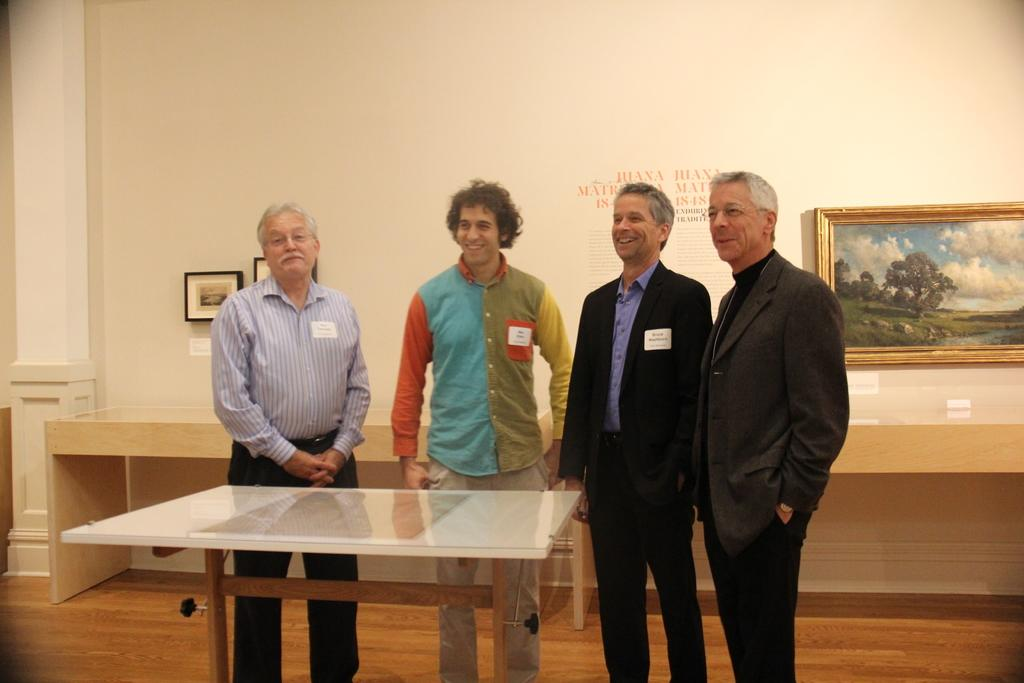How many people are in the image? There are four men in the image. What is the facial expression of the men in the image? The men are smiling. What type of furniture is present in the image? There is a white table in the image. What can be seen on the wall in the background of the image? There is a frame on the wall in the background of the image. What type of rail can be seen in the image? There is no rail present in the image. Is there a ghost visible in the image? There is no ghost present in the image. 